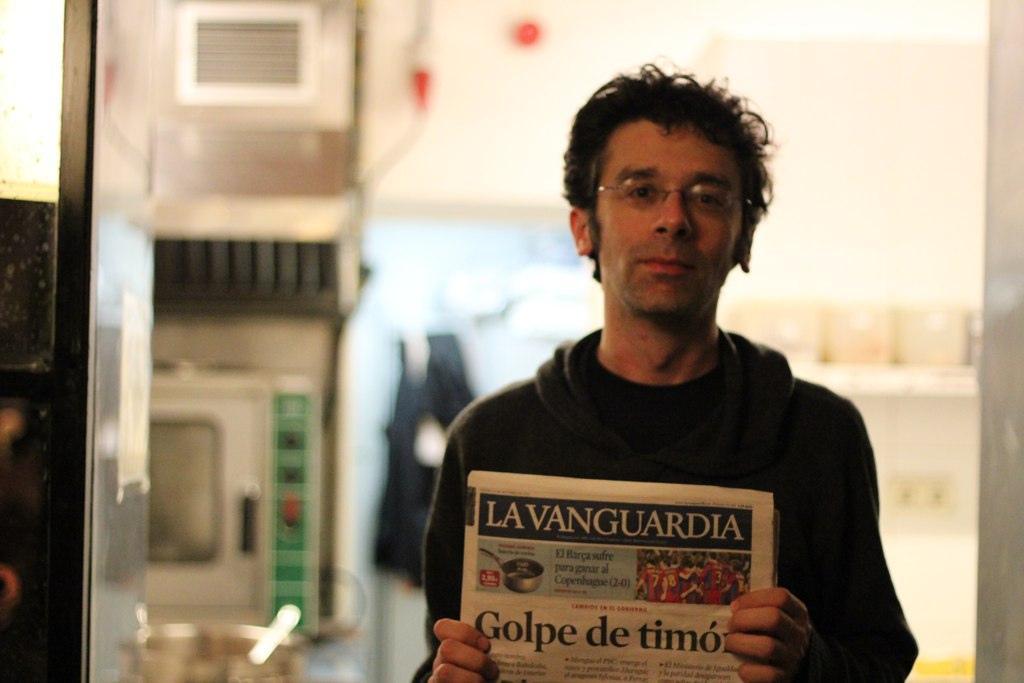Describe this image in one or two sentences. In the image there is a man, he is holding some papers in his hand and the background of the man is blur. 